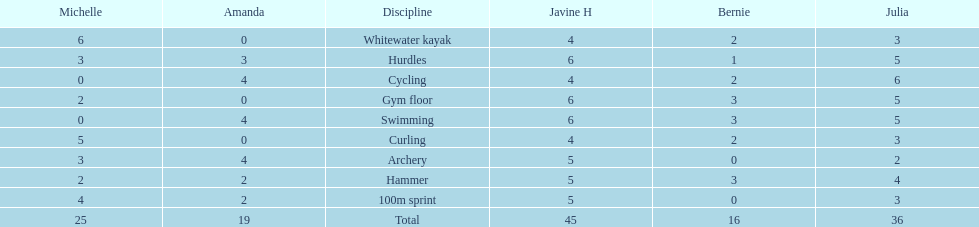Write the full table. {'header': ['Michelle', 'Amanda', 'Discipline', 'Javine H', 'Bernie', 'Julia'], 'rows': [['6', '0', 'Whitewater kayak', '4', '2', '3'], ['3', '3', 'Hurdles', '6', '1', '5'], ['0', '4', 'Cycling', '4', '2', '6'], ['2', '0', 'Gym floor', '6', '3', '5'], ['0', '4', 'Swimming', '6', '3', '5'], ['5', '0', 'Curling', '4', '2', '3'], ['3', '4', 'Archery', '5', '0', '2'], ['2', '2', 'Hammer', '5', '3', '4'], ['4', '2', '100m sprint', '5', '0', '3'], ['25', '19', 'Total', '45', '16', '36']]} Which of the girls had the least amount in archery? Bernie. 